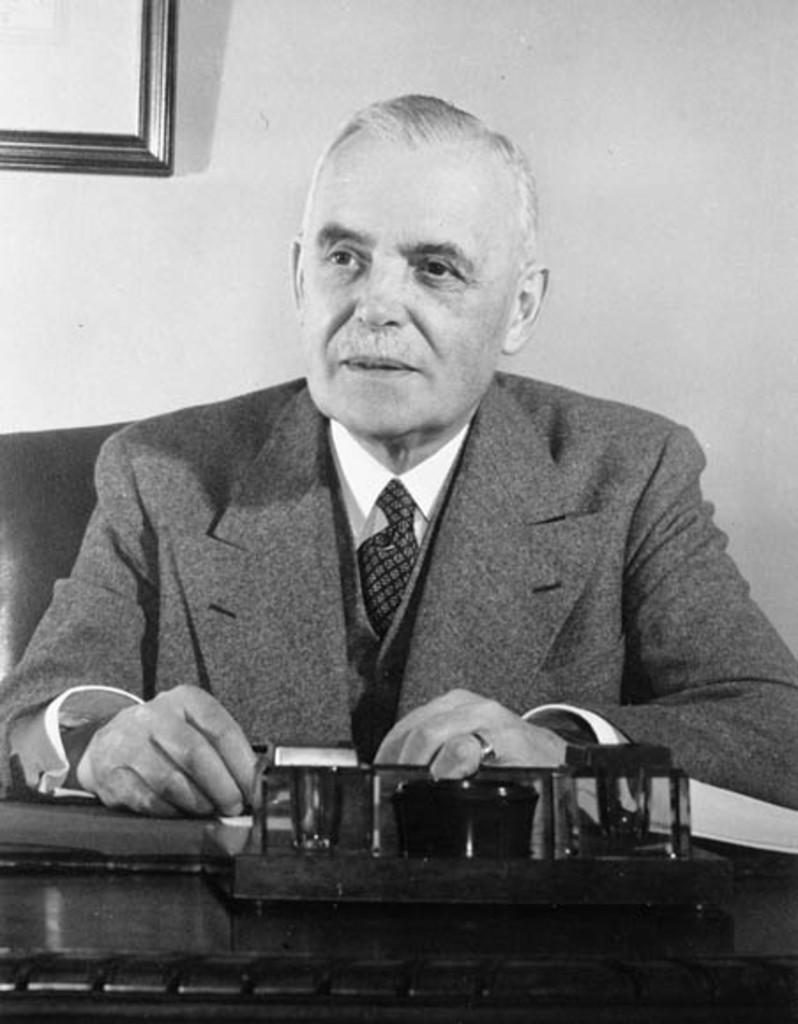In one or two sentences, can you explain what this image depicts? In this picture there is a man who is wearing suit. He is sitting on the chair. On the table I can see some wooden object. In the top left corner there is a frame which is placed on the wall. 